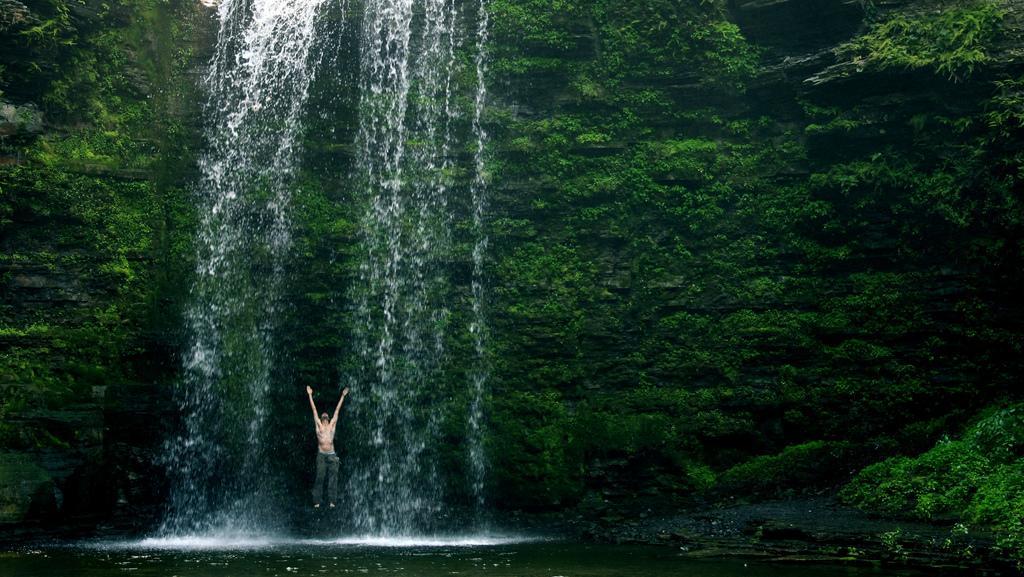Can you describe this image briefly? In the foreground of the image we can see water body. In the middle of the image we can see water body, trees and a person is standing on the water. On the top of the image we can see water body and trees. By seeing this image we can say a person is standing under a waterfall. 